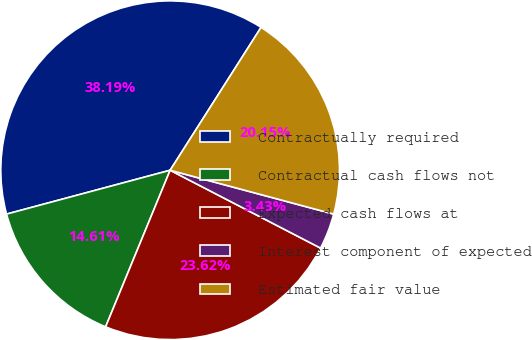<chart> <loc_0><loc_0><loc_500><loc_500><pie_chart><fcel>Contractually required<fcel>Contractual cash flows not<fcel>Expected cash flows at<fcel>Interest component of expected<fcel>Estimated fair value<nl><fcel>38.19%<fcel>14.61%<fcel>23.62%<fcel>3.43%<fcel>20.15%<nl></chart> 